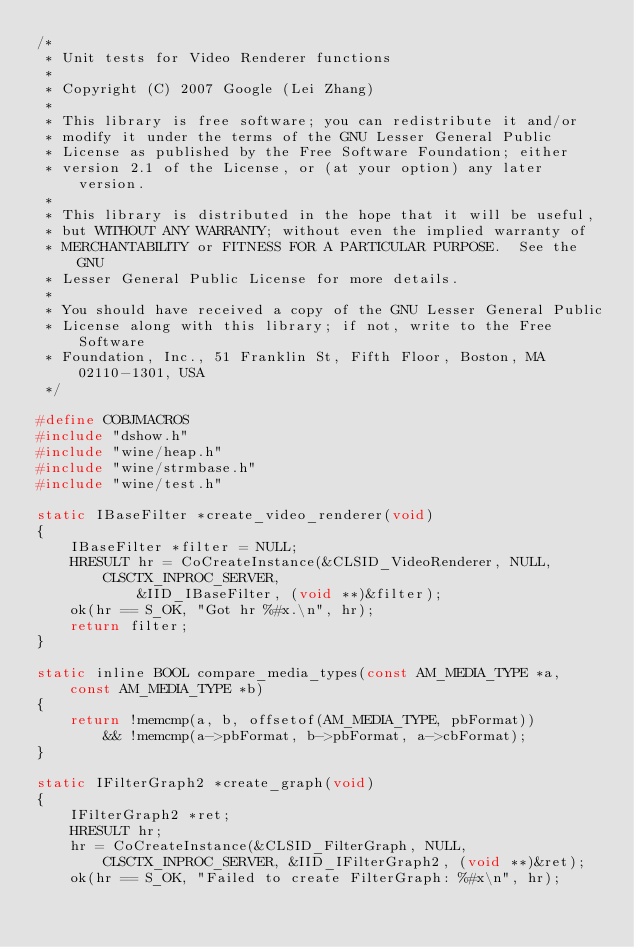<code> <loc_0><loc_0><loc_500><loc_500><_C_>/*
 * Unit tests for Video Renderer functions
 *
 * Copyright (C) 2007 Google (Lei Zhang)
 *
 * This library is free software; you can redistribute it and/or
 * modify it under the terms of the GNU Lesser General Public
 * License as published by the Free Software Foundation; either
 * version 2.1 of the License, or (at your option) any later version.
 *
 * This library is distributed in the hope that it will be useful,
 * but WITHOUT ANY WARRANTY; without even the implied warranty of
 * MERCHANTABILITY or FITNESS FOR A PARTICULAR PURPOSE.  See the GNU
 * Lesser General Public License for more details.
 *
 * You should have received a copy of the GNU Lesser General Public
 * License along with this library; if not, write to the Free Software
 * Foundation, Inc., 51 Franklin St, Fifth Floor, Boston, MA 02110-1301, USA
 */

#define COBJMACROS
#include "dshow.h"
#include "wine/heap.h"
#include "wine/strmbase.h"
#include "wine/test.h"

static IBaseFilter *create_video_renderer(void)
{
    IBaseFilter *filter = NULL;
    HRESULT hr = CoCreateInstance(&CLSID_VideoRenderer, NULL, CLSCTX_INPROC_SERVER,
            &IID_IBaseFilter, (void **)&filter);
    ok(hr == S_OK, "Got hr %#x.\n", hr);
    return filter;
}

static inline BOOL compare_media_types(const AM_MEDIA_TYPE *a, const AM_MEDIA_TYPE *b)
{
    return !memcmp(a, b, offsetof(AM_MEDIA_TYPE, pbFormat))
        && !memcmp(a->pbFormat, b->pbFormat, a->cbFormat);
}

static IFilterGraph2 *create_graph(void)
{
    IFilterGraph2 *ret;
    HRESULT hr;
    hr = CoCreateInstance(&CLSID_FilterGraph, NULL, CLSCTX_INPROC_SERVER, &IID_IFilterGraph2, (void **)&ret);
    ok(hr == S_OK, "Failed to create FilterGraph: %#x\n", hr);</code> 